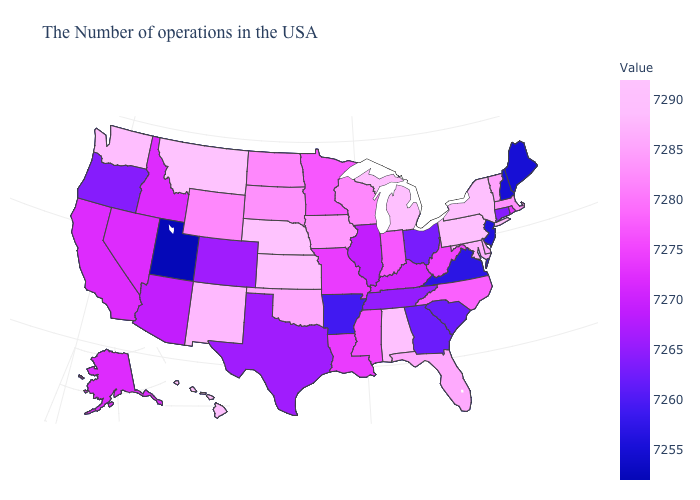Among the states that border Washington , does Oregon have the lowest value?
Give a very brief answer. Yes. Does Nebraska have the highest value in the MidWest?
Give a very brief answer. Yes. Is the legend a continuous bar?
Be succinct. Yes. Does Wisconsin have a higher value than New York?
Keep it brief. No. Does Virginia have the lowest value in the South?
Give a very brief answer. Yes. Which states hav the highest value in the Northeast?
Concise answer only. New York, Pennsylvania. 